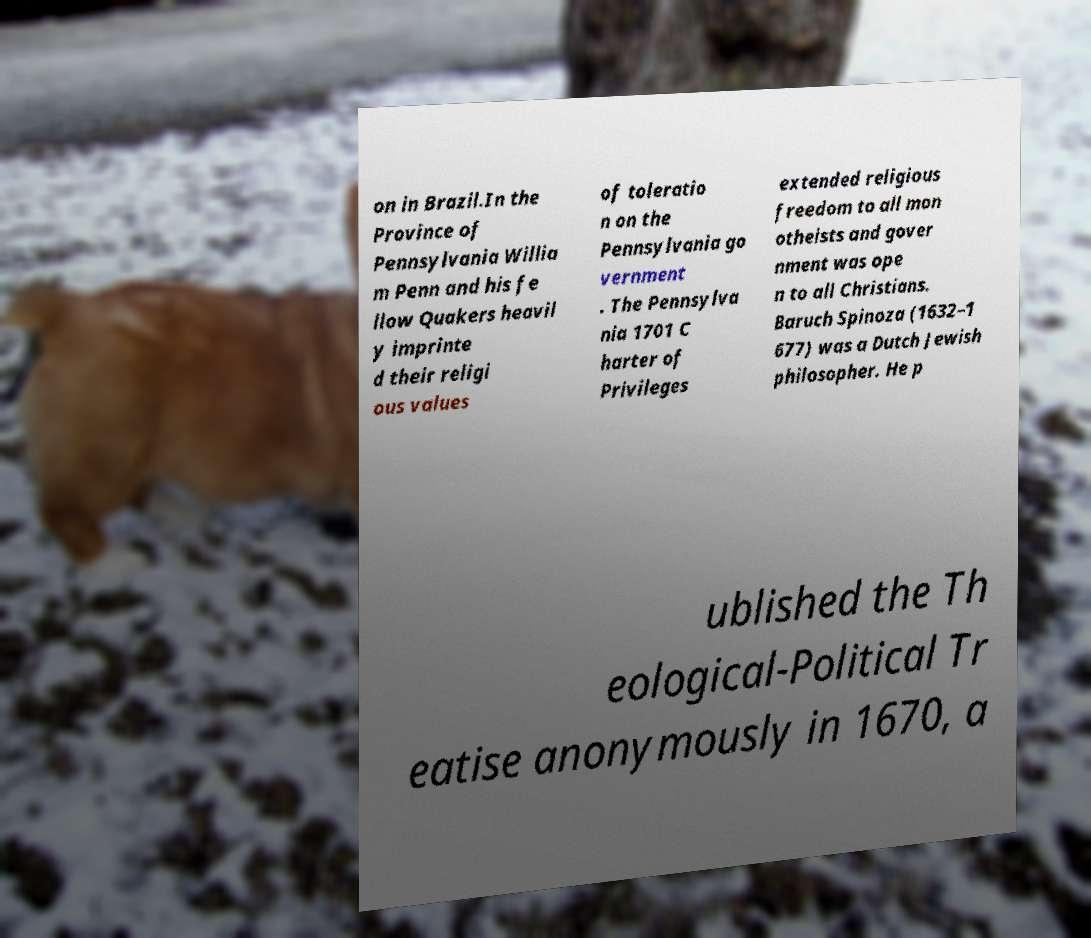I need the written content from this picture converted into text. Can you do that? on in Brazil.In the Province of Pennsylvania Willia m Penn and his fe llow Quakers heavil y imprinte d their religi ous values of toleratio n on the Pennsylvania go vernment . The Pennsylva nia 1701 C harter of Privileges extended religious freedom to all mon otheists and gover nment was ope n to all Christians. Baruch Spinoza (1632–1 677) was a Dutch Jewish philosopher. He p ublished the Th eological-Political Tr eatise anonymously in 1670, a 